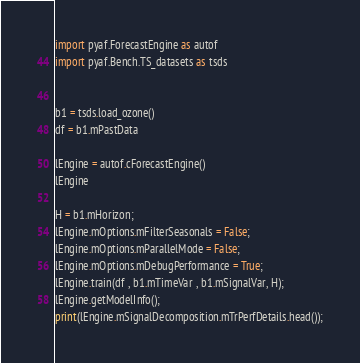Convert code to text. <code><loc_0><loc_0><loc_500><loc_500><_Python_>
import pyaf.ForecastEngine as autof
import pyaf.Bench.TS_datasets as tsds


b1 = tsds.load_ozone()
df = b1.mPastData

lEngine = autof.cForecastEngine()
lEngine

H = b1.mHorizon;
lEngine.mOptions.mFilterSeasonals = False;
lEngine.mOptions.mParallelMode = False;
lEngine.mOptions.mDebugPerformance = True;
lEngine.train(df , b1.mTimeVar , b1.mSignalVar, H);
lEngine.getModelInfo();
print(lEngine.mSignalDecomposition.mTrPerfDetails.head());

</code> 